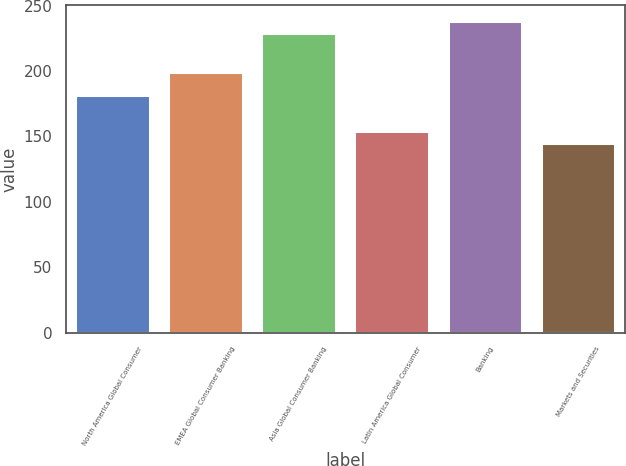Convert chart to OTSL. <chart><loc_0><loc_0><loc_500><loc_500><bar_chart><fcel>North America Global Consumer<fcel>EMEA Global Consumer Banking<fcel>Asia Global Consumer Banking<fcel>Latin America Global Consumer<fcel>Banking<fcel>Markets and Securities<nl><fcel>182<fcel>199<fcel>229<fcel>154.2<fcel>238.2<fcel>145<nl></chart> 